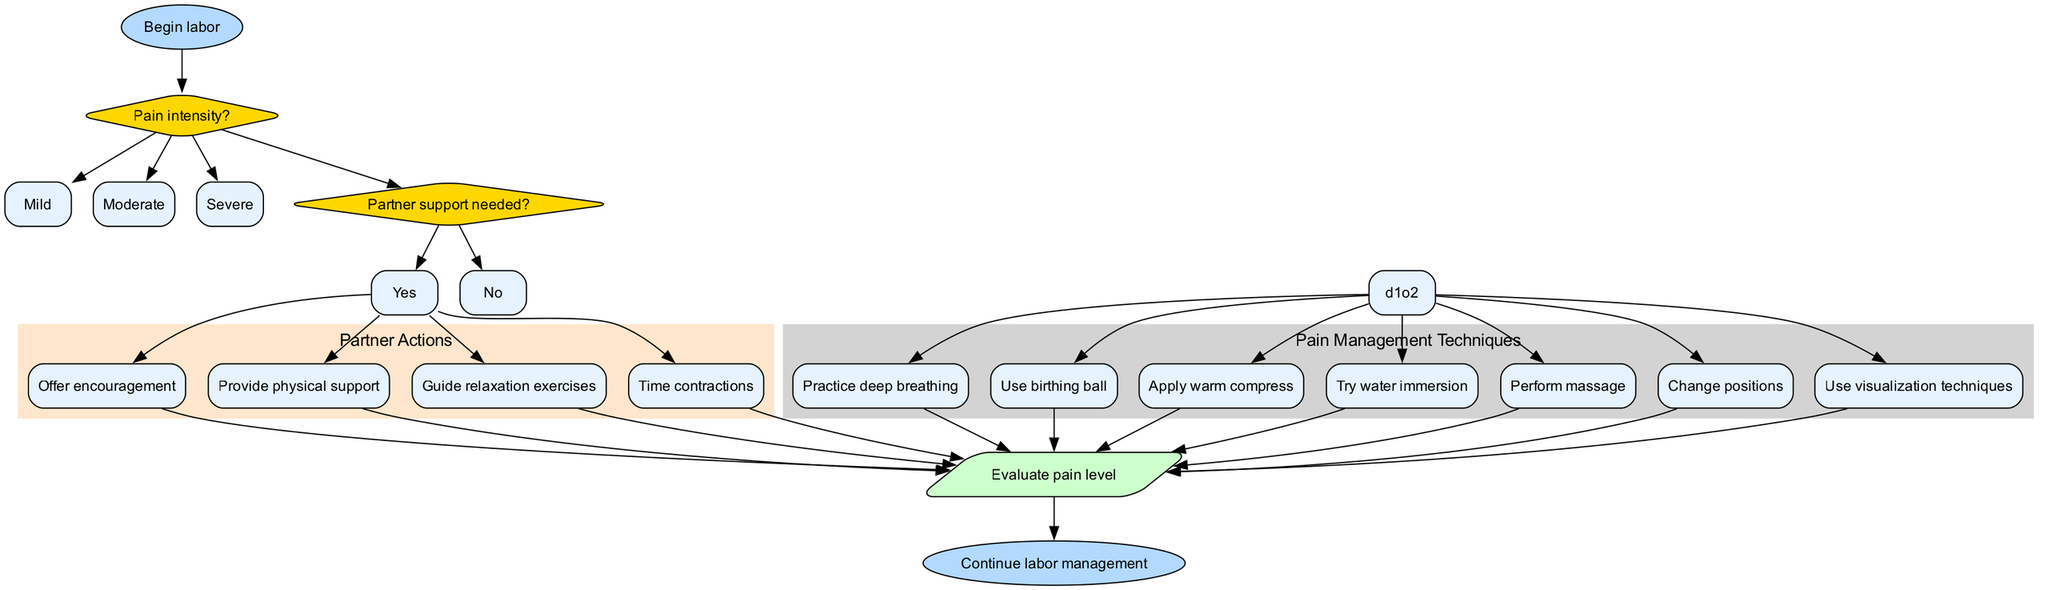What is the starting point of the flowchart? The starting point is indicated by the first node, labeled 'Begin labor'.
Answer: Begin labor How many decision nodes are in the diagram? There are two decision nodes, one for 'Pain intensity?' and another for 'Partner support needed?'.
Answer: 2 What options are available for the 'Pain intensity?' decision? The options listed under the 'Pain intensity?' decision node include 'Mild', 'Moderate', and 'Severe'.
Answer: Mild, Moderate, Severe What action should be taken if 'Partner support needed?' is 'Yes'? If 'Partner support needed?' is 'Yes', the diagram shows that it leads to partner actions such as 'Offer encouragement' and 'Provide physical support'.
Answer: Offer encouragement, Provide physical support What is the step that follows the 'techniques' cluster? After the 'techniques' cluster, the next step is 'Reassess', indicating an evaluation of pain levels after applying the techniques.
Answer: Reassess If the pain intensity is 'Severe', how many techniques can be applied? Regardless of the pain intensity (including 'Severe'), all techniques from the 'Pain Management Techniques' cluster can be utilized, which total to 7 techniques.
Answer: 7 Which partner action connects to 'reassess'? All partner actions connect to 'reassess', but specifically, 'Guide relaxation exercises' is one of the actions that connects.
Answer: Guide relaxation exercises What is the final step in the flowchart? The final step in the flowchart is labeled 'Continue labor management'.
Answer: Continue labor management What does the 'reassess' node indicate after applying techniques? The 'reassess' node indicates that the pain level should be evaluated again after the application of the techniques to determine the next course of action.
Answer: Evaluate pain level 